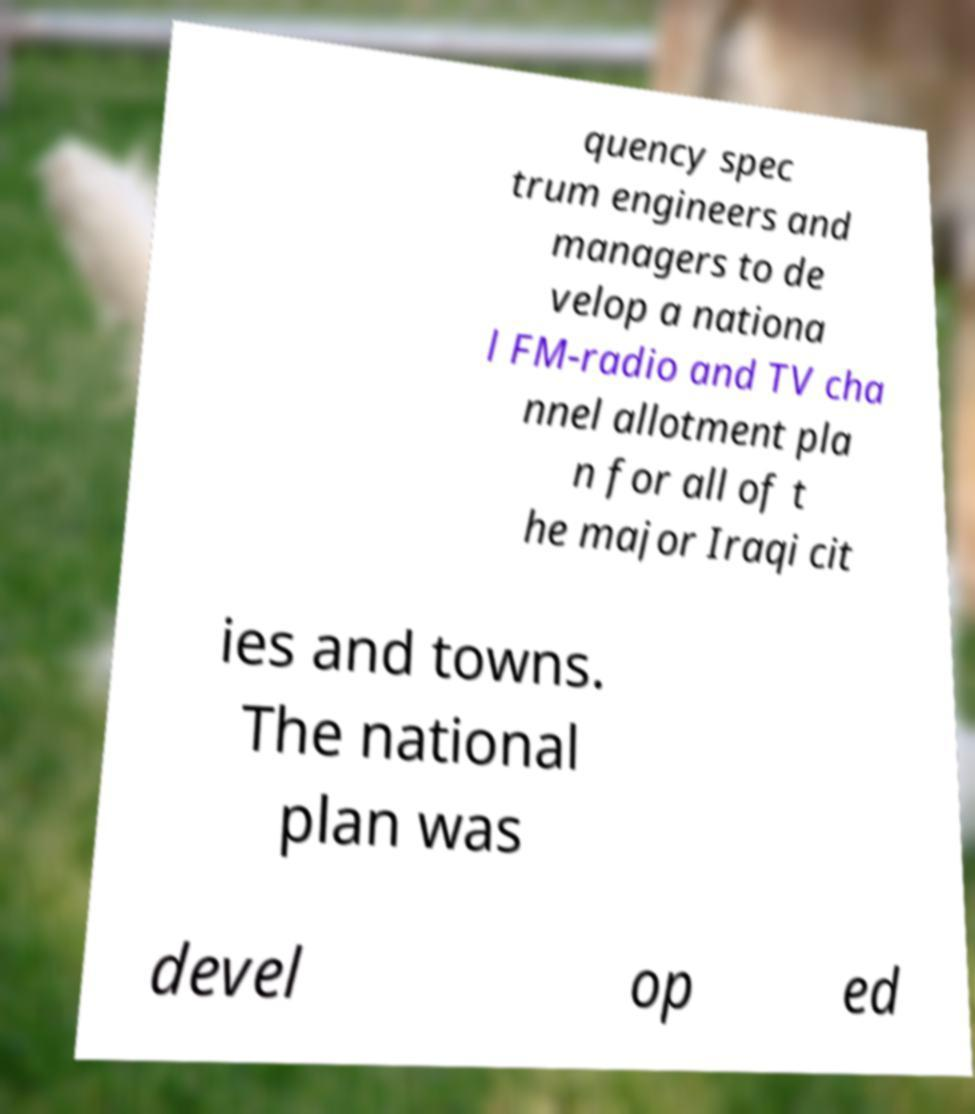Can you read and provide the text displayed in the image?This photo seems to have some interesting text. Can you extract and type it out for me? quency spec trum engineers and managers to de velop a nationa l FM-radio and TV cha nnel allotment pla n for all of t he major Iraqi cit ies and towns. The national plan was devel op ed 